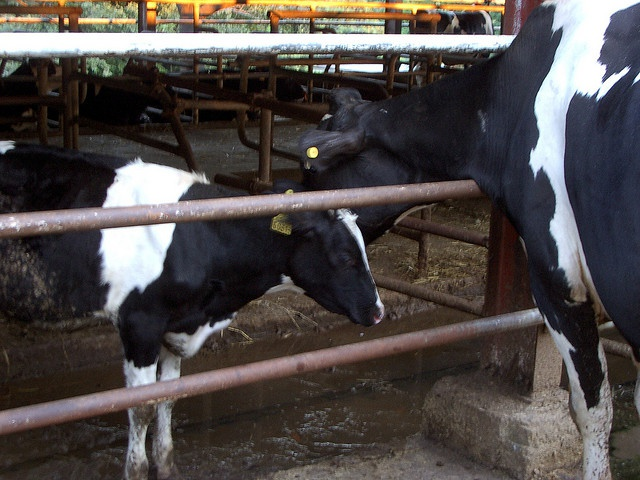Describe the objects in this image and their specific colors. I can see cow in black, white, and gray tones, cow in black, white, darkgray, and gray tones, cow in black, maroon, and teal tones, and cow in black, gray, darkgray, and lightgray tones in this image. 